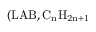<formula> <loc_0><loc_0><loc_500><loc_500>( L A B , C _ { n } H _ { 2 n + 1 }</formula> 